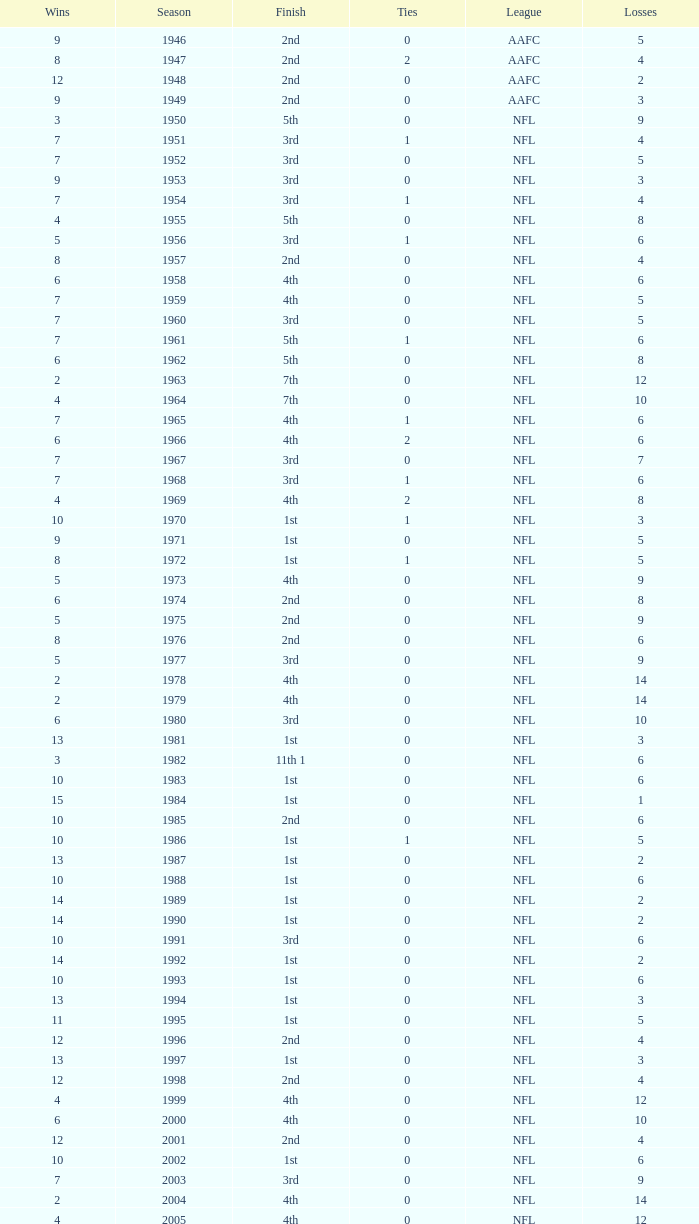What is the number of losses when the ties are lesser than 0? 0.0. 